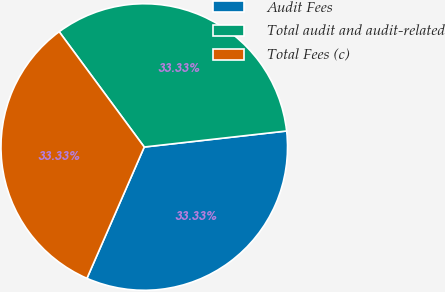Convert chart to OTSL. <chart><loc_0><loc_0><loc_500><loc_500><pie_chart><fcel>Audit Fees<fcel>Total audit and audit-related<fcel>Total Fees (c)<nl><fcel>33.33%<fcel>33.33%<fcel>33.33%<nl></chart> 